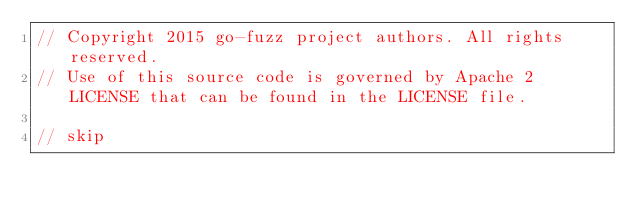Convert code to text. <code><loc_0><loc_0><loc_500><loc_500><_Go_>// Copyright 2015 go-fuzz project authors. All rights reserved.
// Use of this source code is governed by Apache 2 LICENSE that can be found in the LICENSE file.

// skip</code> 